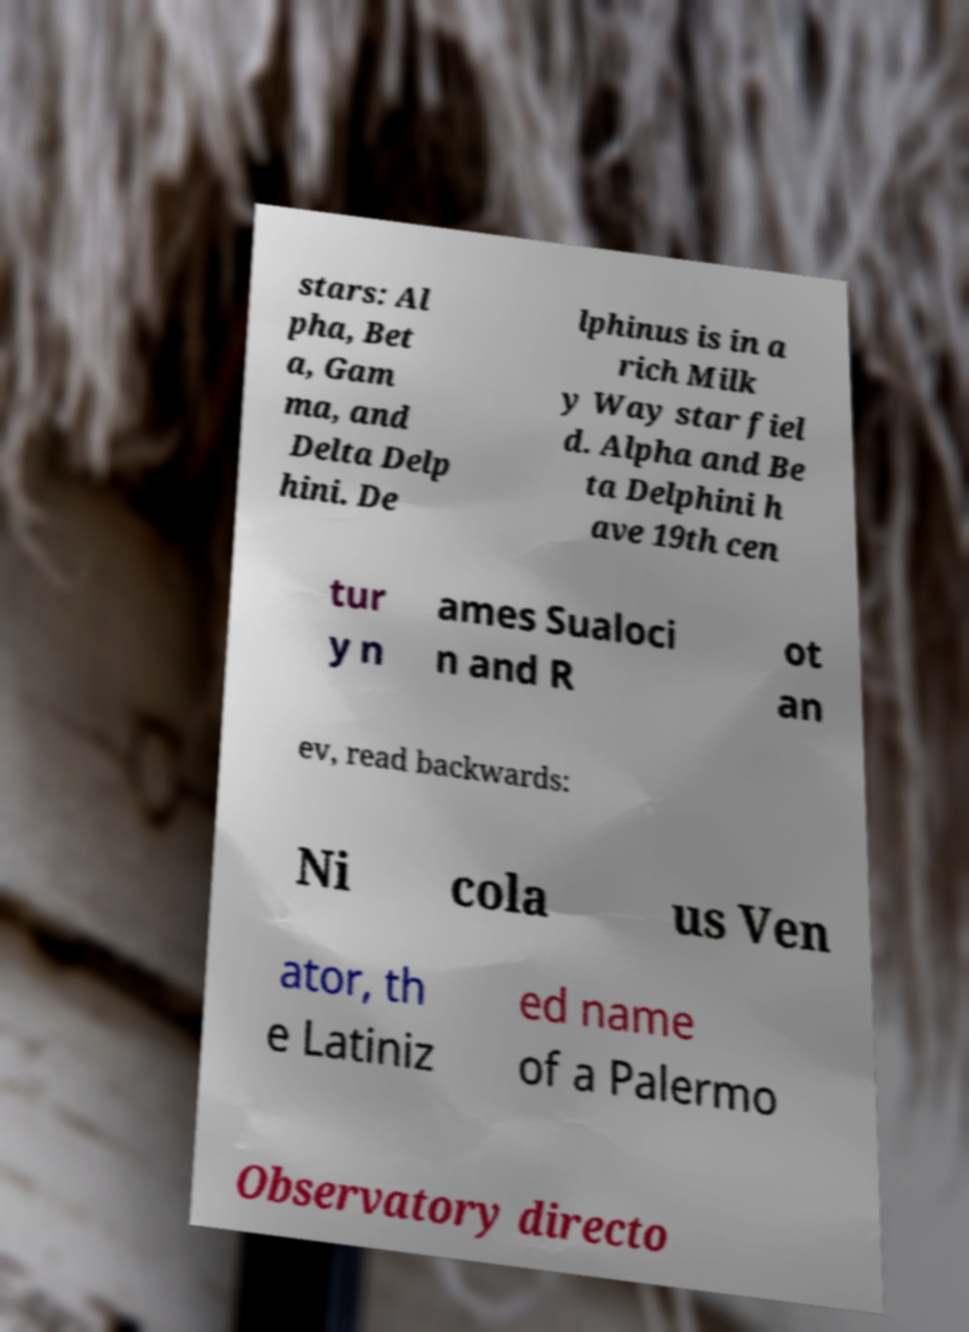I need the written content from this picture converted into text. Can you do that? stars: Al pha, Bet a, Gam ma, and Delta Delp hini. De lphinus is in a rich Milk y Way star fiel d. Alpha and Be ta Delphini h ave 19th cen tur y n ames Sualoci n and R ot an ev, read backwards: Ni cola us Ven ator, th e Latiniz ed name of a Palermo Observatory directo 